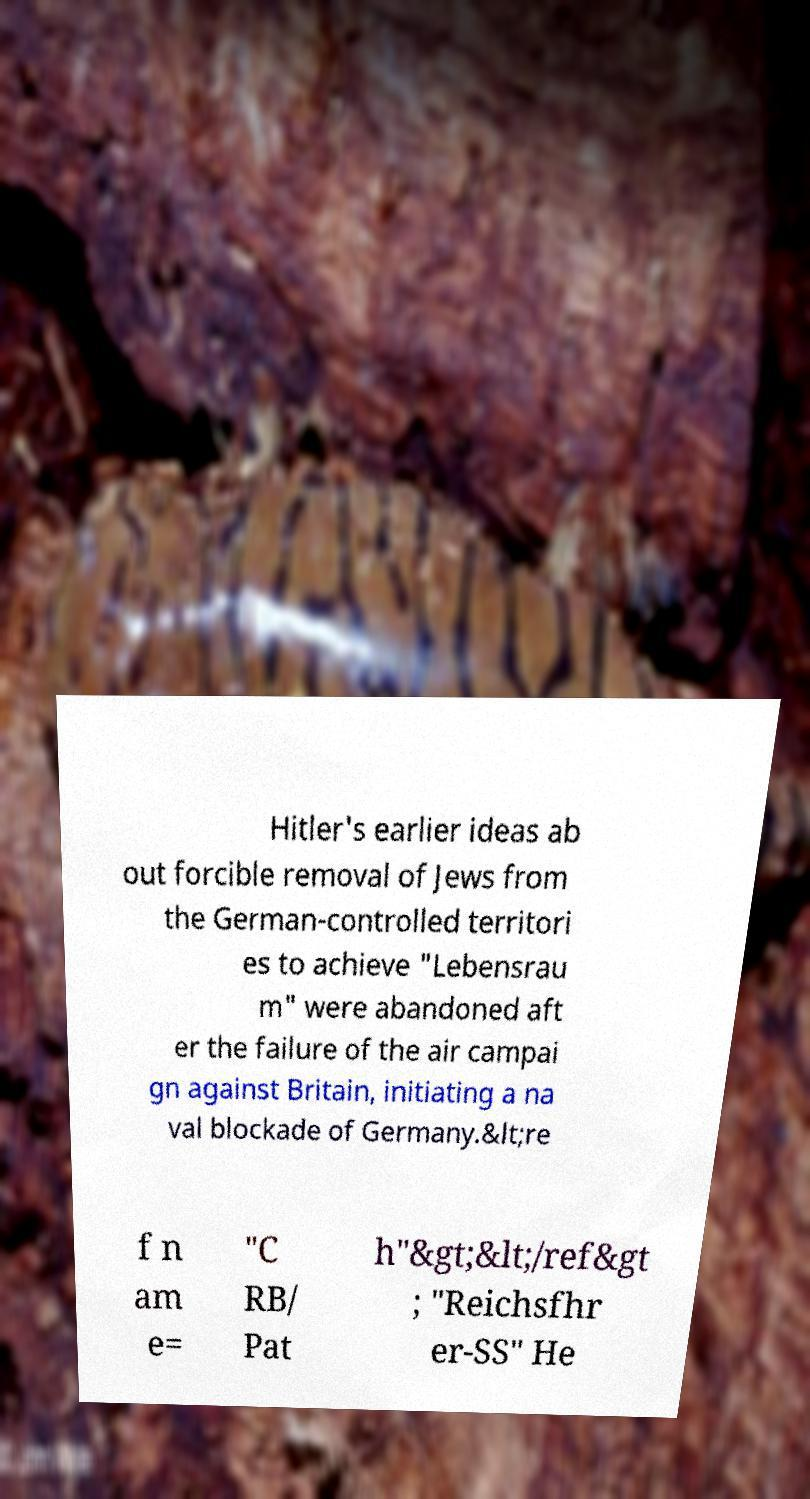Could you assist in decoding the text presented in this image and type it out clearly? Hitler's earlier ideas ab out forcible removal of Jews from the German-controlled territori es to achieve "Lebensrau m" were abandoned aft er the failure of the air campai gn against Britain, initiating a na val blockade of Germany.&lt;re f n am e= "C RB/ Pat h"&gt;&lt;/ref&gt ; "Reichsfhr er-SS" He 